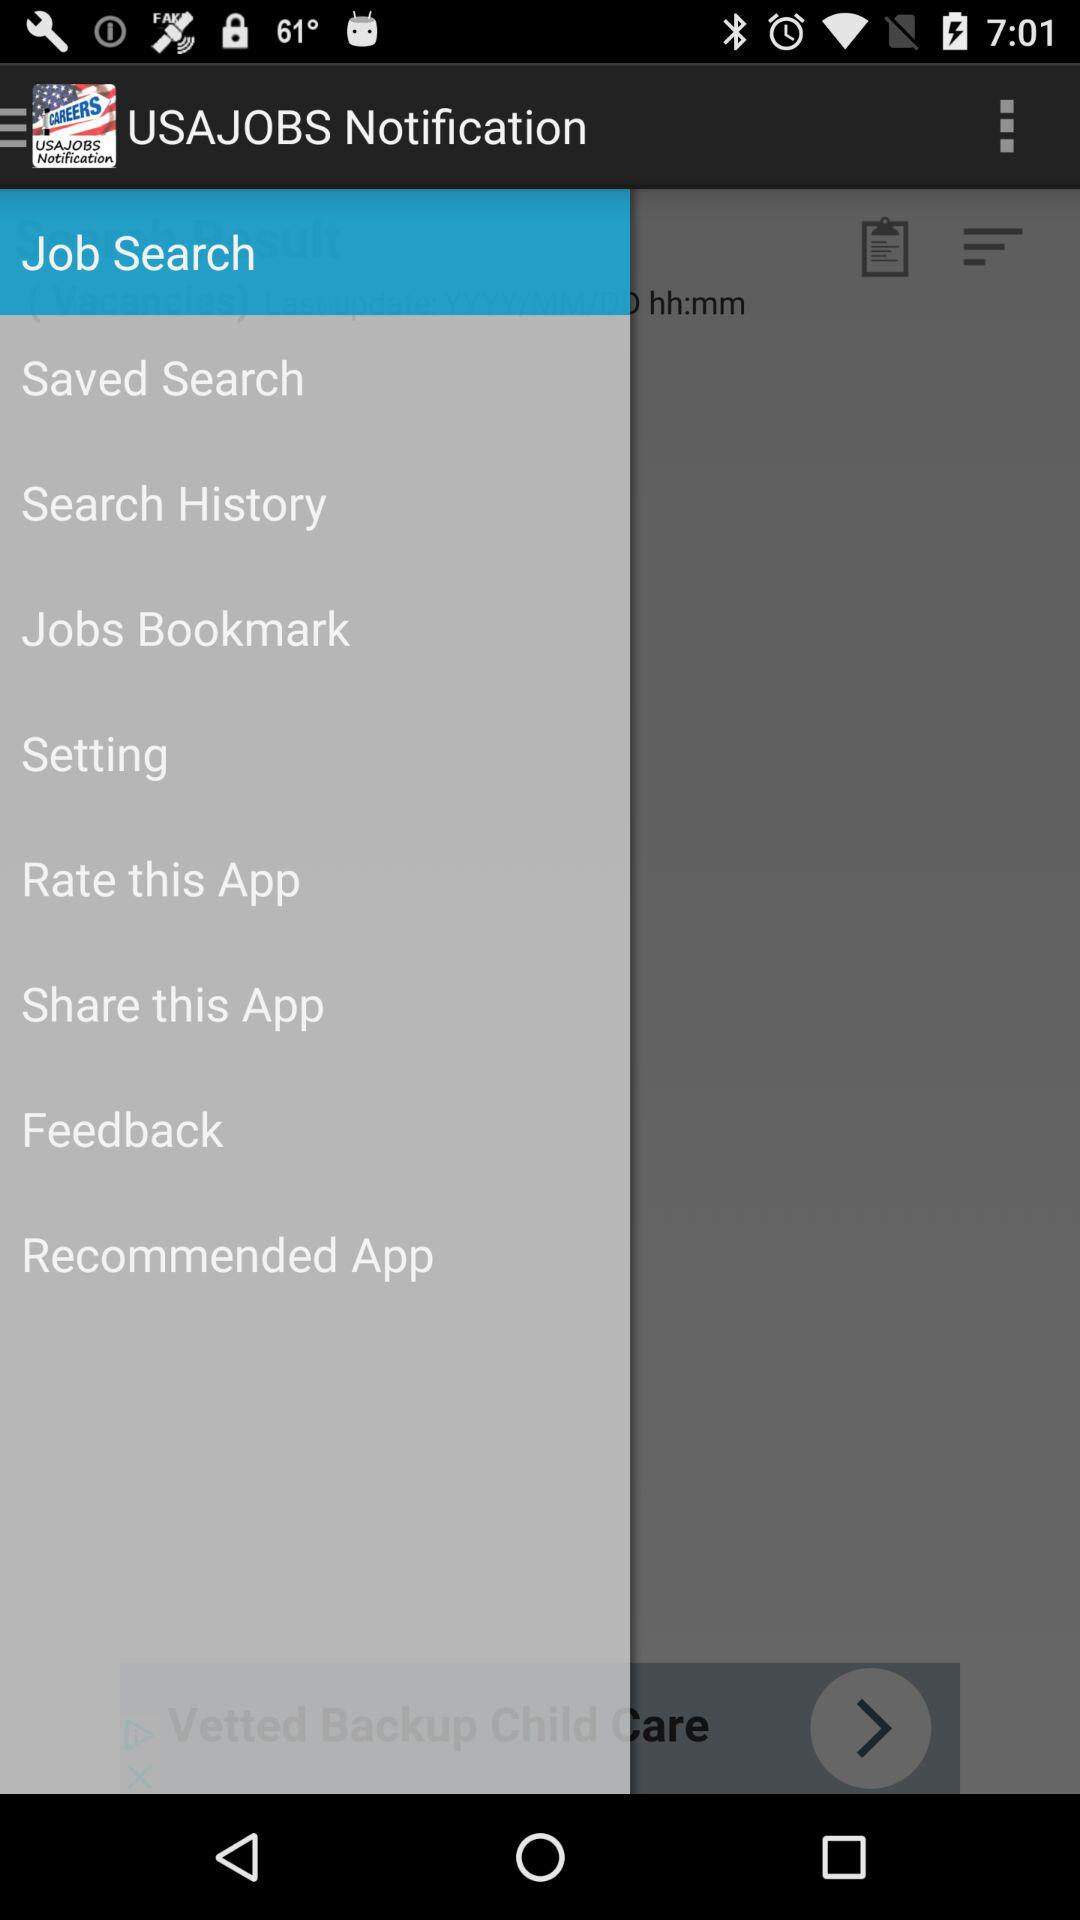How many notifications are there in "Setting"?
When the provided information is insufficient, respond with <no answer>. <no answer> 